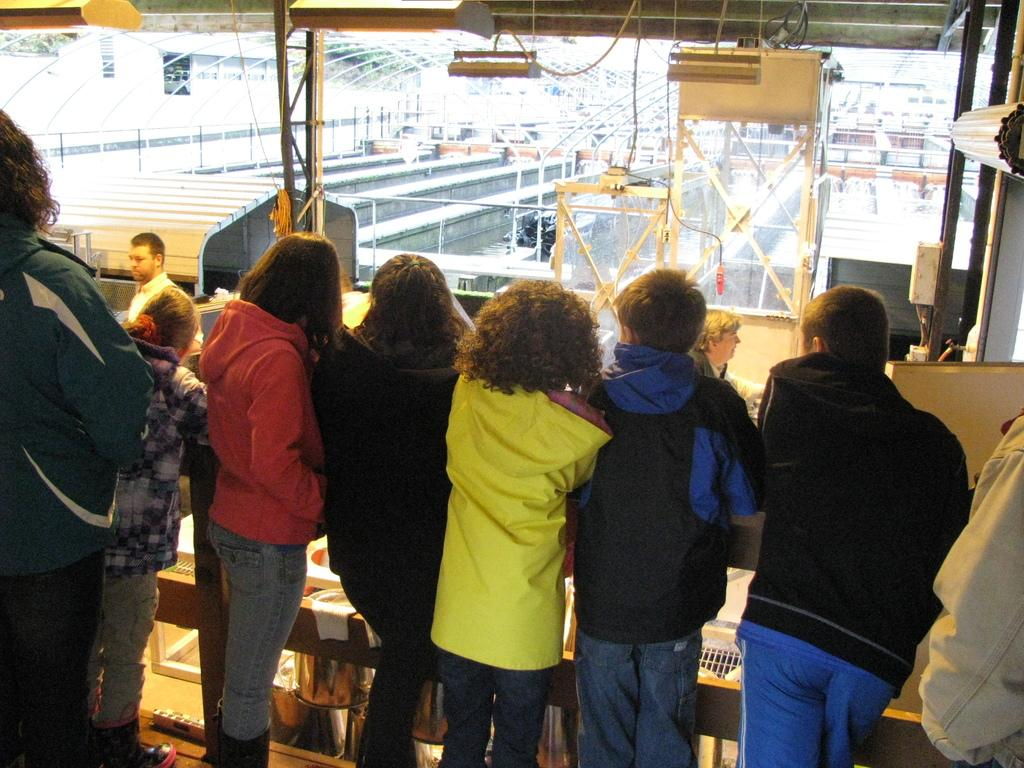What can be seen in the foreground of the image? There are persons standing in the front of the image. What is visible in the background of the image? There are objects, stands, and poles in the background of the image. What colors are the objects in the background? The objects in the background are yellow and white in color. What type of jewel is being sold at the chance booth in the image? There is no mention of a chance booth or any jewels in the image. The image only shows persons standing in the front and objects, stands, and poles in the background. --- Facts: 1. There is a person holding a book in the image. 2. The book has a blue cover. 3. The person is sitting on a chair. 4. There is a table in the image. 5. The table has a lamp on it. Absurd Topics: parrot, ocean, dance Conversation: What is the person in the image holding? The person in the image is holding a book. What color is the book's cover? The book has a blue cover. What is the person sitting on in the image? The person is sitting on a chair. What can be seen on the table in the image? There is a lamp on the table in the image. Reasoning: Let's think step by step in order to produce the conversation. We start by identifying the main subject in the image, which is the person holding a book. Then, we describe the book's cover color, the person's seating arrangement, and the object on the table. Each question is designed to elicit a specific detail about the image that is known from the provided facts. Absurd Question/Answer: Can you tell me how many parrots are sitting on the person's shoulder in the image? There are no parrots present in the image. The image only shows a person holding a book with a blue cover, sitting on a chair, and a table with a lamp on it. 